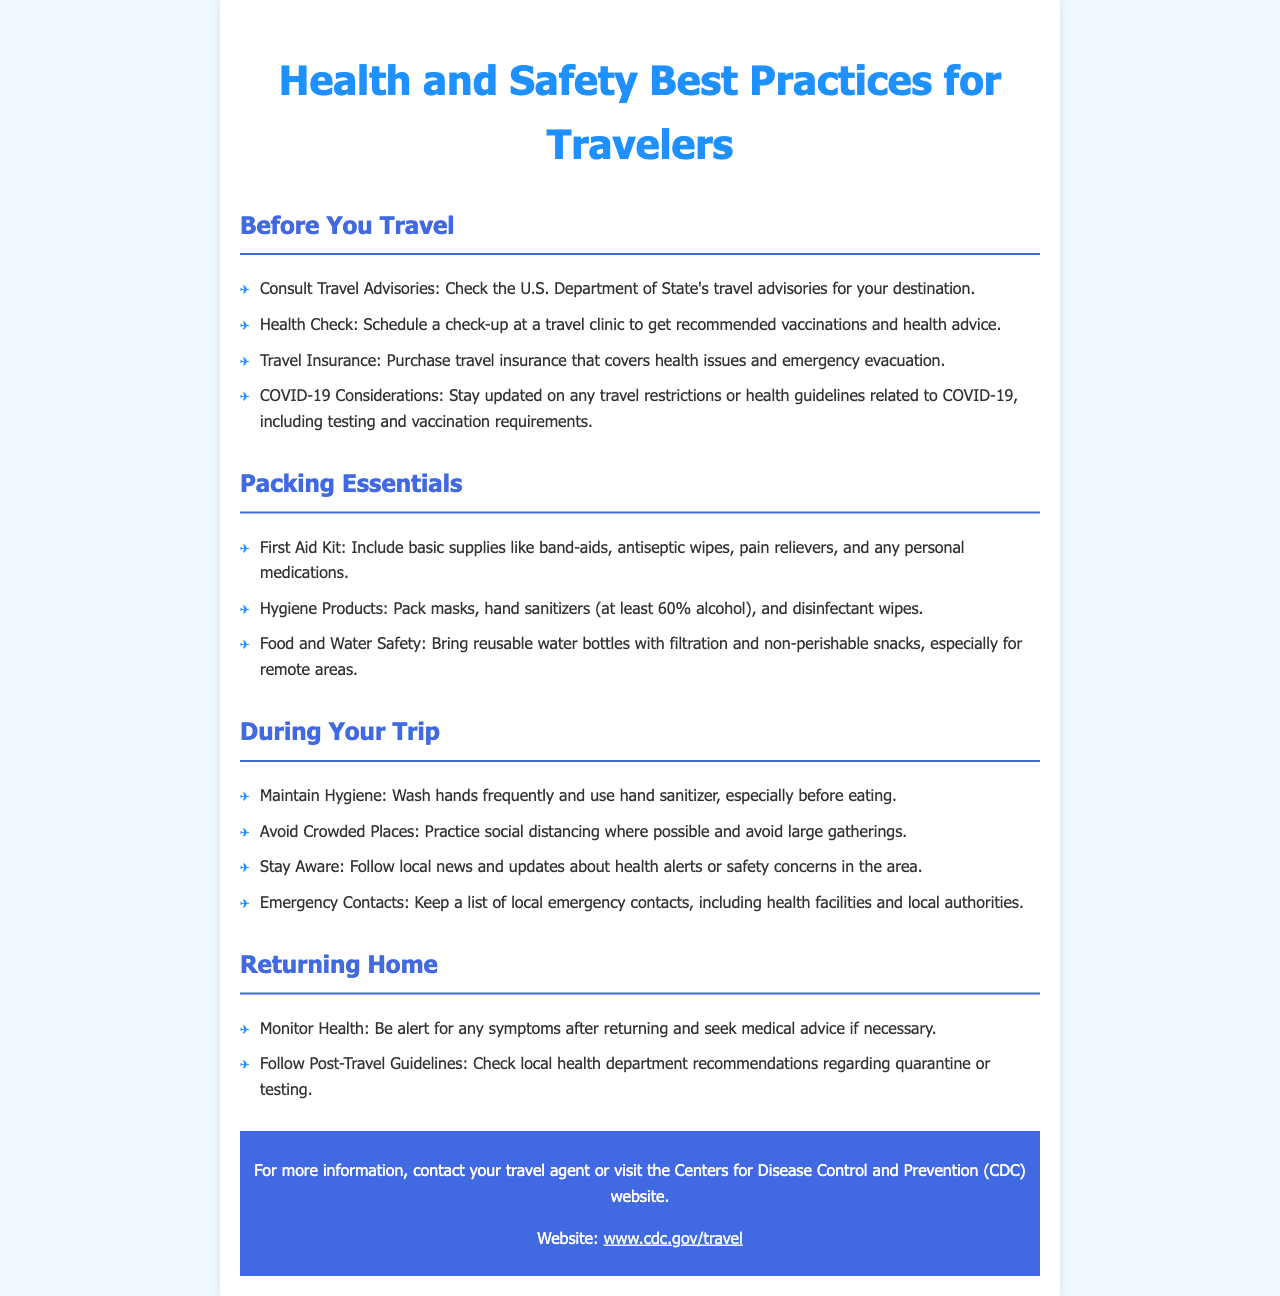What should you consult before traveling? The document states to consult travel advisories from the U.S. Department of State for your destination.
Answer: Travel advisories What items should be included in a first aid kit? The brochure lists basic supplies like band-aids, antiseptic wipes, pain relievers, and any personal medications.
Answer: Band-aids, antiseptic wipes, pain relievers What is a key hygiene product to pack? The document mentions packing masks and hand sanitizers as essential hygiene products.
Answer: Masks, hand sanitizers What precaution should you take regarding crowded places? It advises to practice social distancing and avoid large gatherings during the trip.
Answer: Practice social distancing What should you do if you experience symptoms after returning? The brochure suggests seeking medical advice if necessary after returning home.
Answer: Seek medical advice How often should you wash your hands during your trip? The document emphasizes the importance of washing hands frequently, particularly before eating.
Answer: Frequently What should you monitor after traveling? The document recommends monitoring health for any symptoms upon returning home.
Answer: Health What organization's website is mentioned for more information? The document refers to the Centers for Disease Control and Prevention (CDC) for further details.
Answer: CDC 